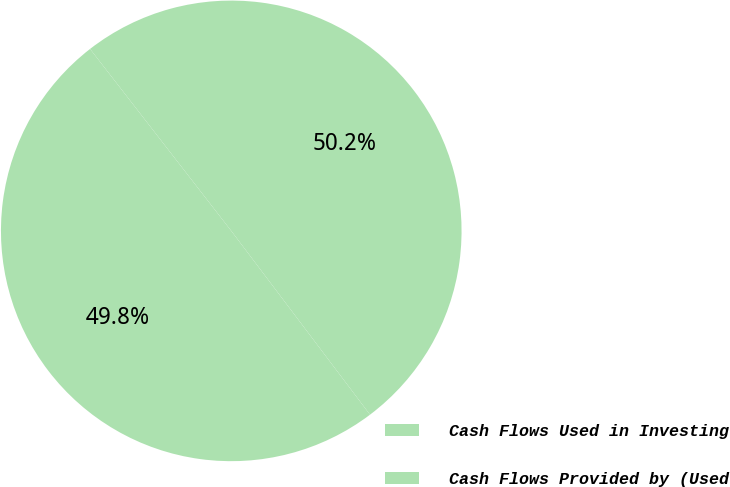Convert chart. <chart><loc_0><loc_0><loc_500><loc_500><pie_chart><fcel>Cash Flows Used in Investing<fcel>Cash Flows Provided by (Used<nl><fcel>50.21%<fcel>49.79%<nl></chart> 